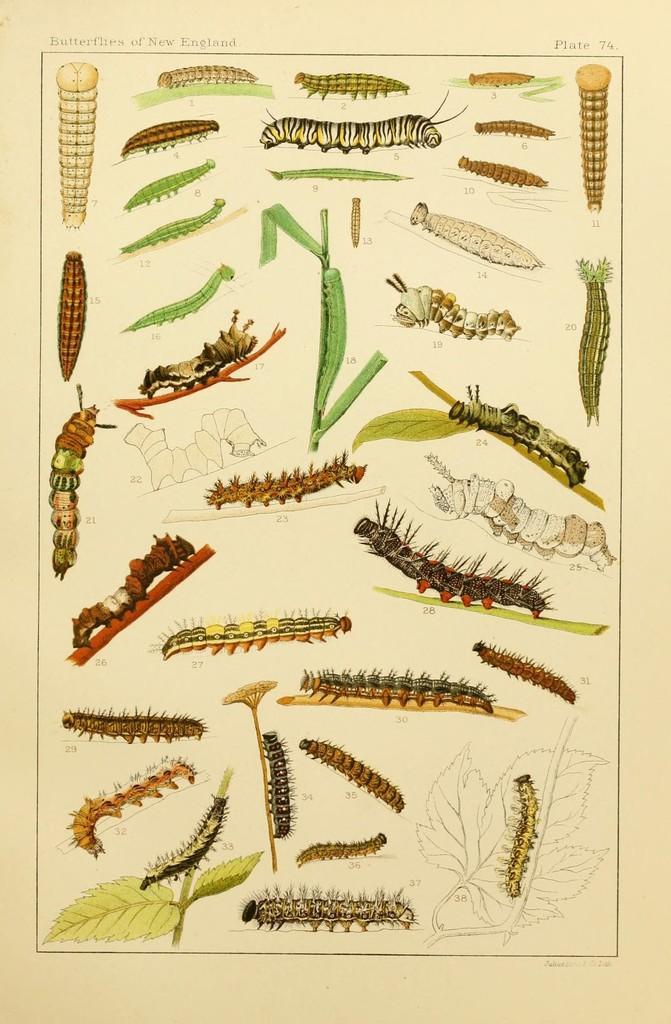How would you summarize this image in a sentence or two? In this image we can see a paper and on the paper we can see different types of insects. There is also text and a number on the paper. 